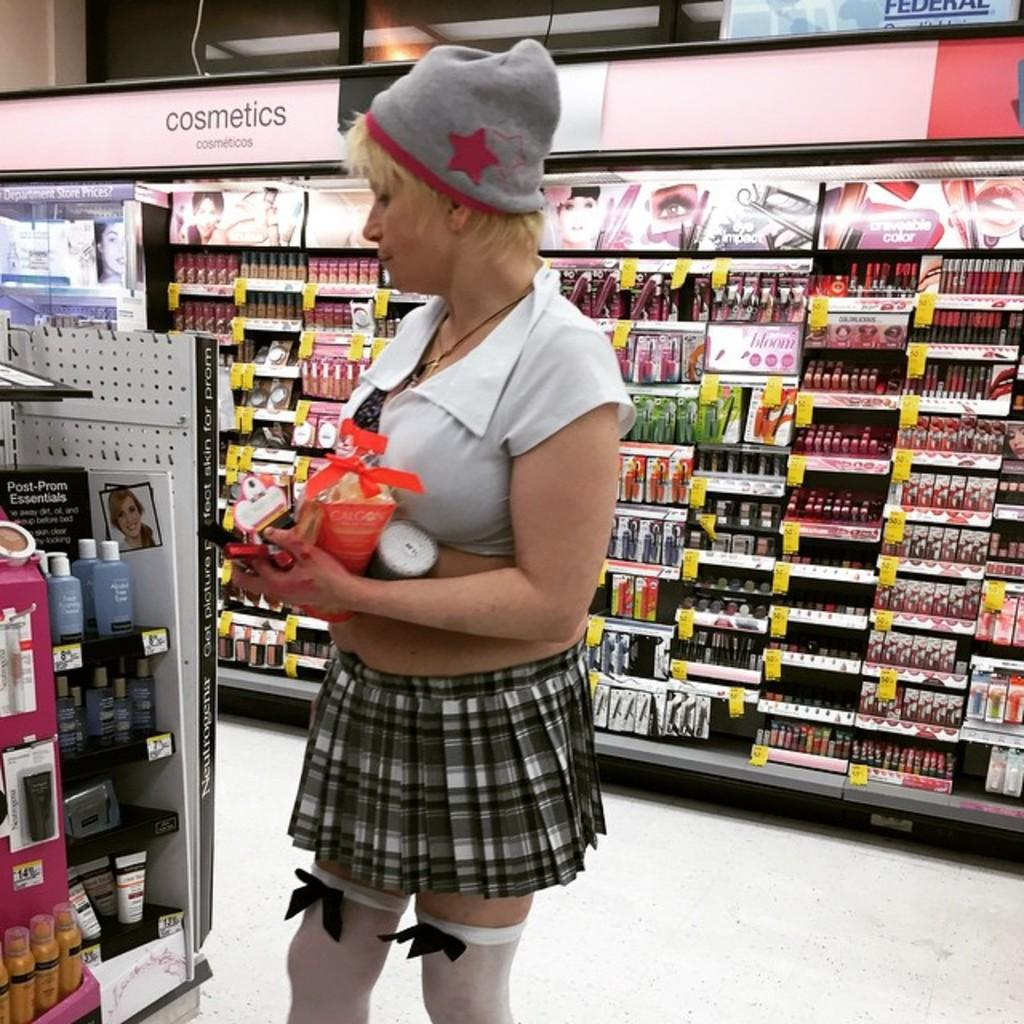<image>
Summarize the visual content of the image. Person wearing a skirt inside a store next to the Cosmetics section. 